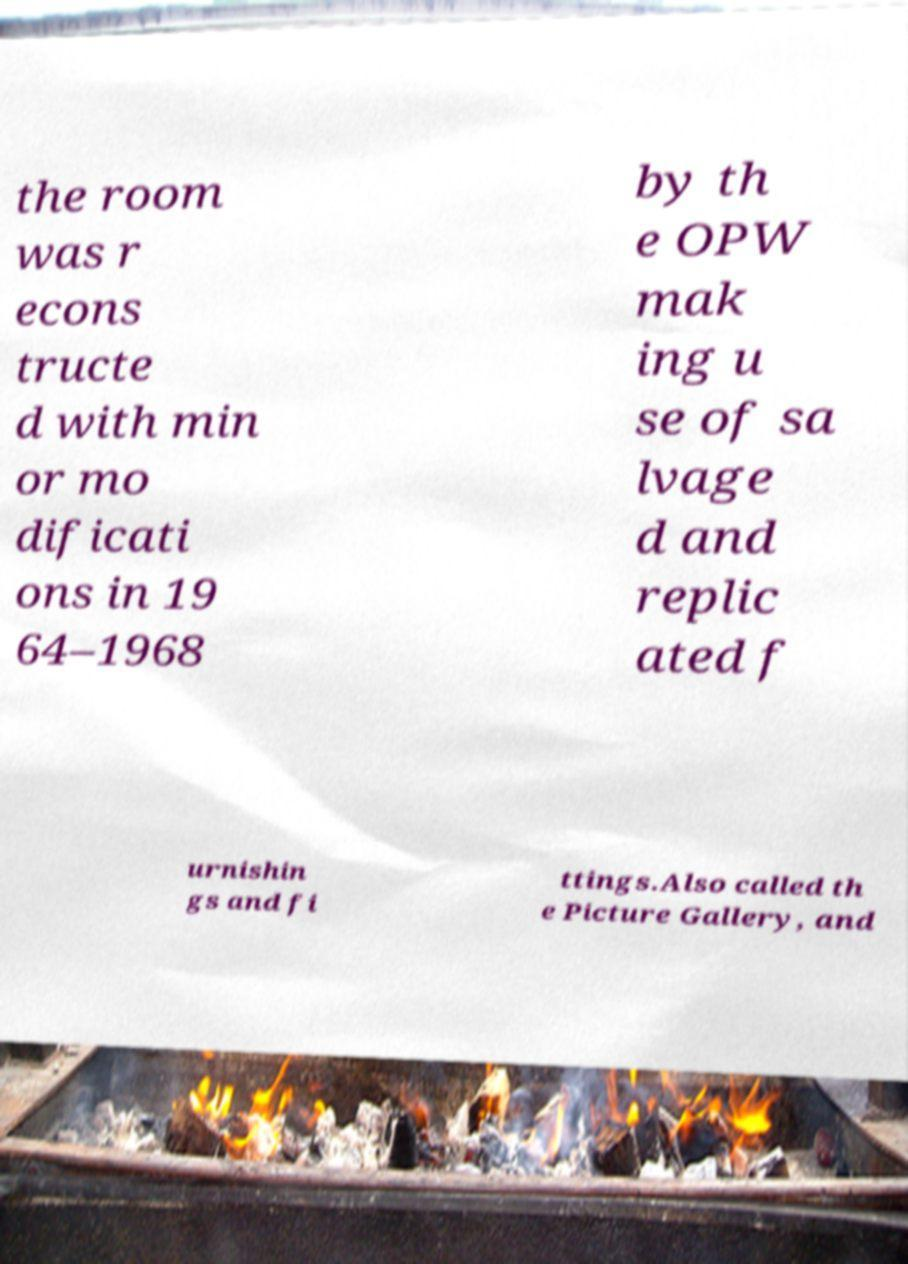What messages or text are displayed in this image? I need them in a readable, typed format. the room was r econs tructe d with min or mo dificati ons in 19 64–1968 by th e OPW mak ing u se of sa lvage d and replic ated f urnishin gs and fi ttings.Also called th e Picture Gallery, and 